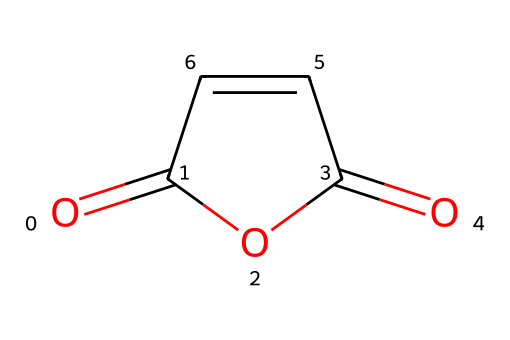What is the name of this compound? The SMILES representation shows a structure with two carbonyl groups (C=O) adjacent to a five-membered ring containing an oxygen atom. This is characteristic of maleic anhydride.
Answer: maleic anhydride How many carbon atoms are in maleic anhydride? Analyzing the SMILES, there are four carbon atoms present in the structure.
Answer: 4 What is the total number of double bonds in this molecule? In the structure, there are two carbon-carbon double bonds and two carbon-oxygen double bonds, totaling four double bonds.
Answer: 4 What functional groups are present in the structure? The structure includes carbonyl (C=O) and an anhydride group, which is typical for an acid anhydride.
Answer: carbonyl and anhydride What type of reaction can maleic anhydride undergo due to its structure? The presence of the anhydride functional group allows it to readily react with water to form maleic acid, which is typical behavior for acid anhydrides.
Answer: hydrolysis How many oxygen atoms are present in maleic anhydride? The SMILES indicates there are two oxygen atoms in the molecule, both part of the carbonyl groups.
Answer: 2 